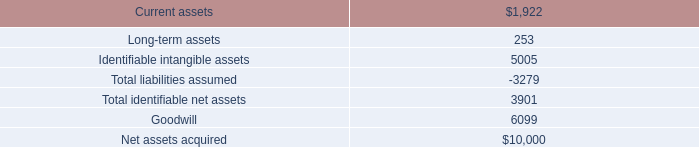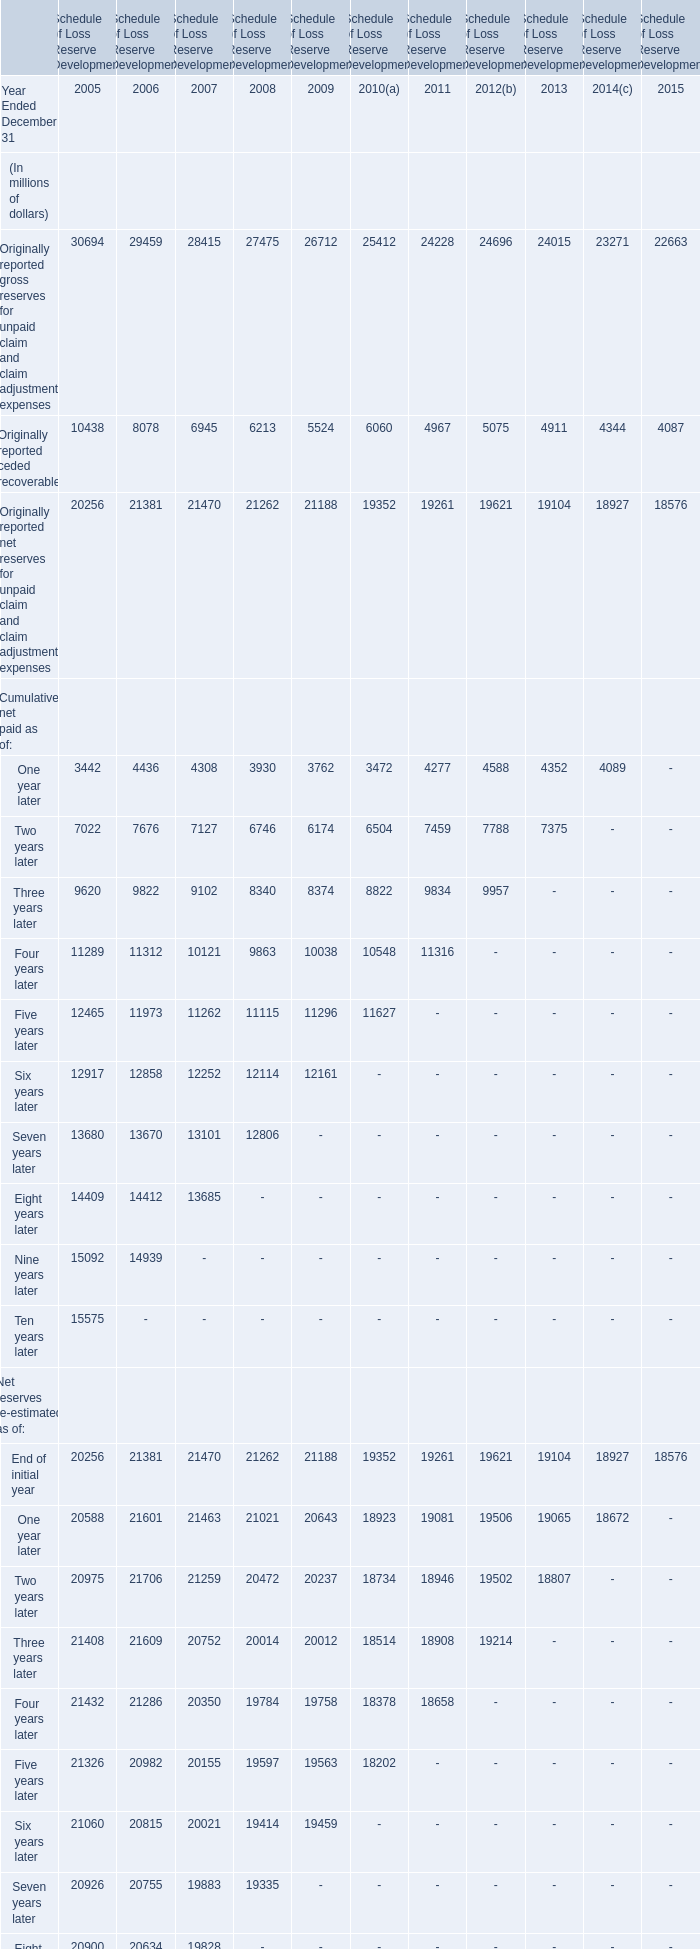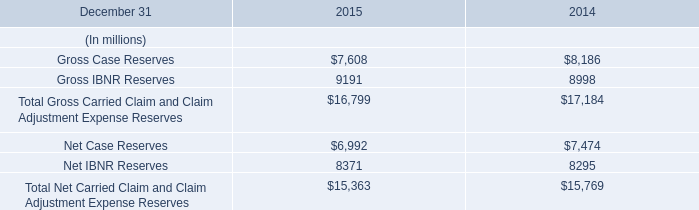what was the percent of the ash in the current assets acquired 
Computations: (1725 / 1922)
Answer: 0.8975. 